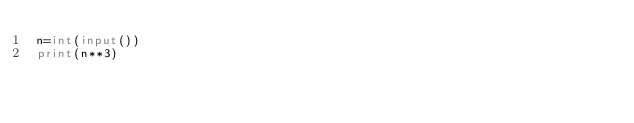<code> <loc_0><loc_0><loc_500><loc_500><_Python_>n=int(input())
print(n**3)</code> 